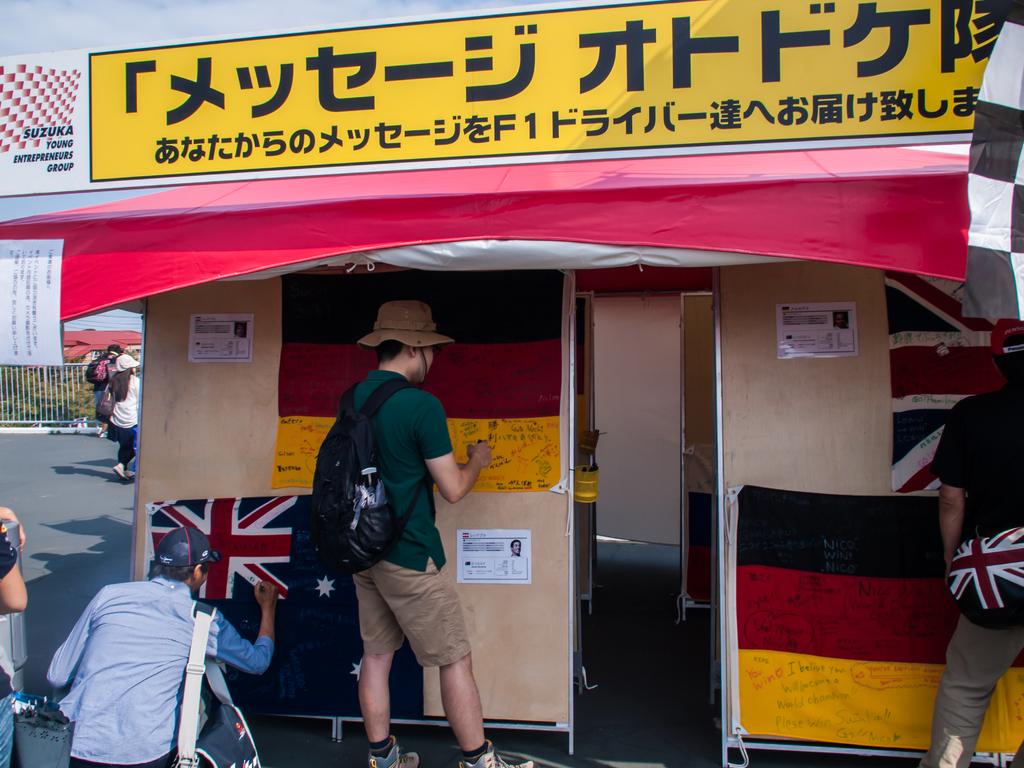Written in a foreign language?
Keep it short and to the point. Yes. 